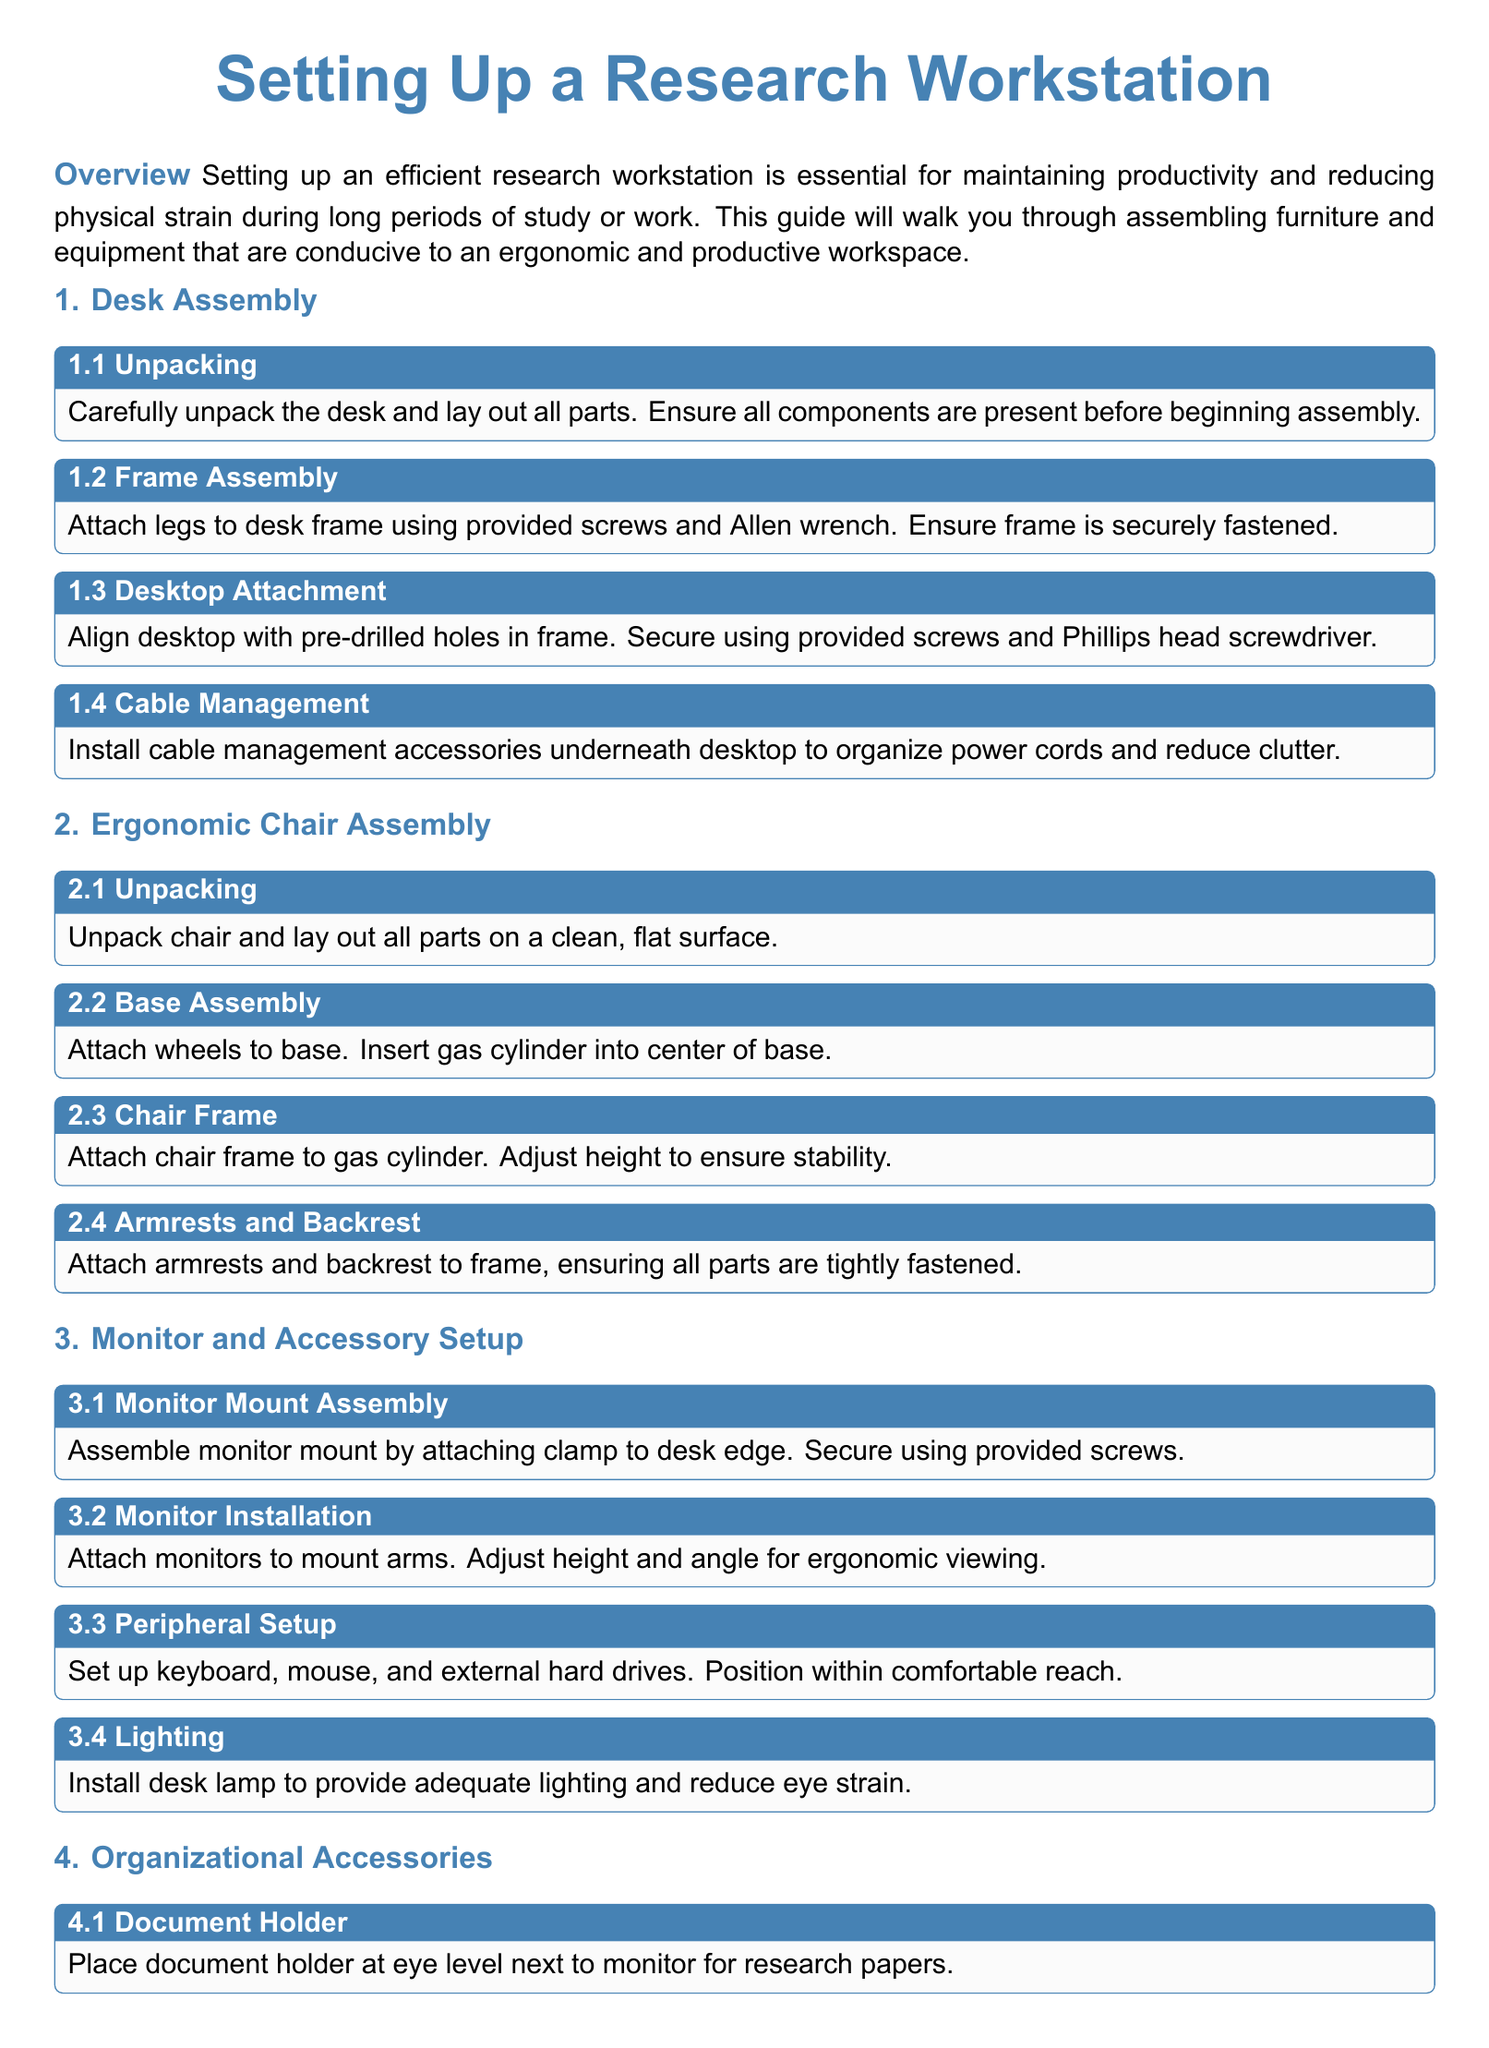What is the title of the document? The title of the document is prominently displayed at the beginning, stating the purpose of setting up a workstation.
Answer: Setting Up a Research Workstation How many steps are in the desk assembly section? The desk assembly section contains four distinct steps outlined clearly.
Answer: 4 What color is used for the main headings? The document specifies that the main headings are presented in a specific color defined in the document geometry settings.
Answer: maincolor What is the purpose of the document holder? The document holder is intended to enhance ergonomics by positioning research papers at a suitable height.
Answer: Eye level What action is suggested for cable management? The document advises the installation of accessories to keep power cords organized and reduce clutter.
Answer: Organize power cords How is the gas cylinder attached to the chair base? The assembly instructions state that the gas cylinder must be inserted into the center of the base during the assembly process.
Answer: Insert What should be added to personalize the workstation? The document encourages adding personal items to create a more inviting and focused workspace.
Answer: Personal items Which tool is mentioned for securing the desktop? The instructions specify using a Phillips head screwdriver to secure the desktop to the frame.
Answer: Phillips head screwdriver What is the suggested position for the keyboard and mouse? The guide recommends positioning these peripherals within comfortable reach for ease of use.
Answer: Comfortable reach 